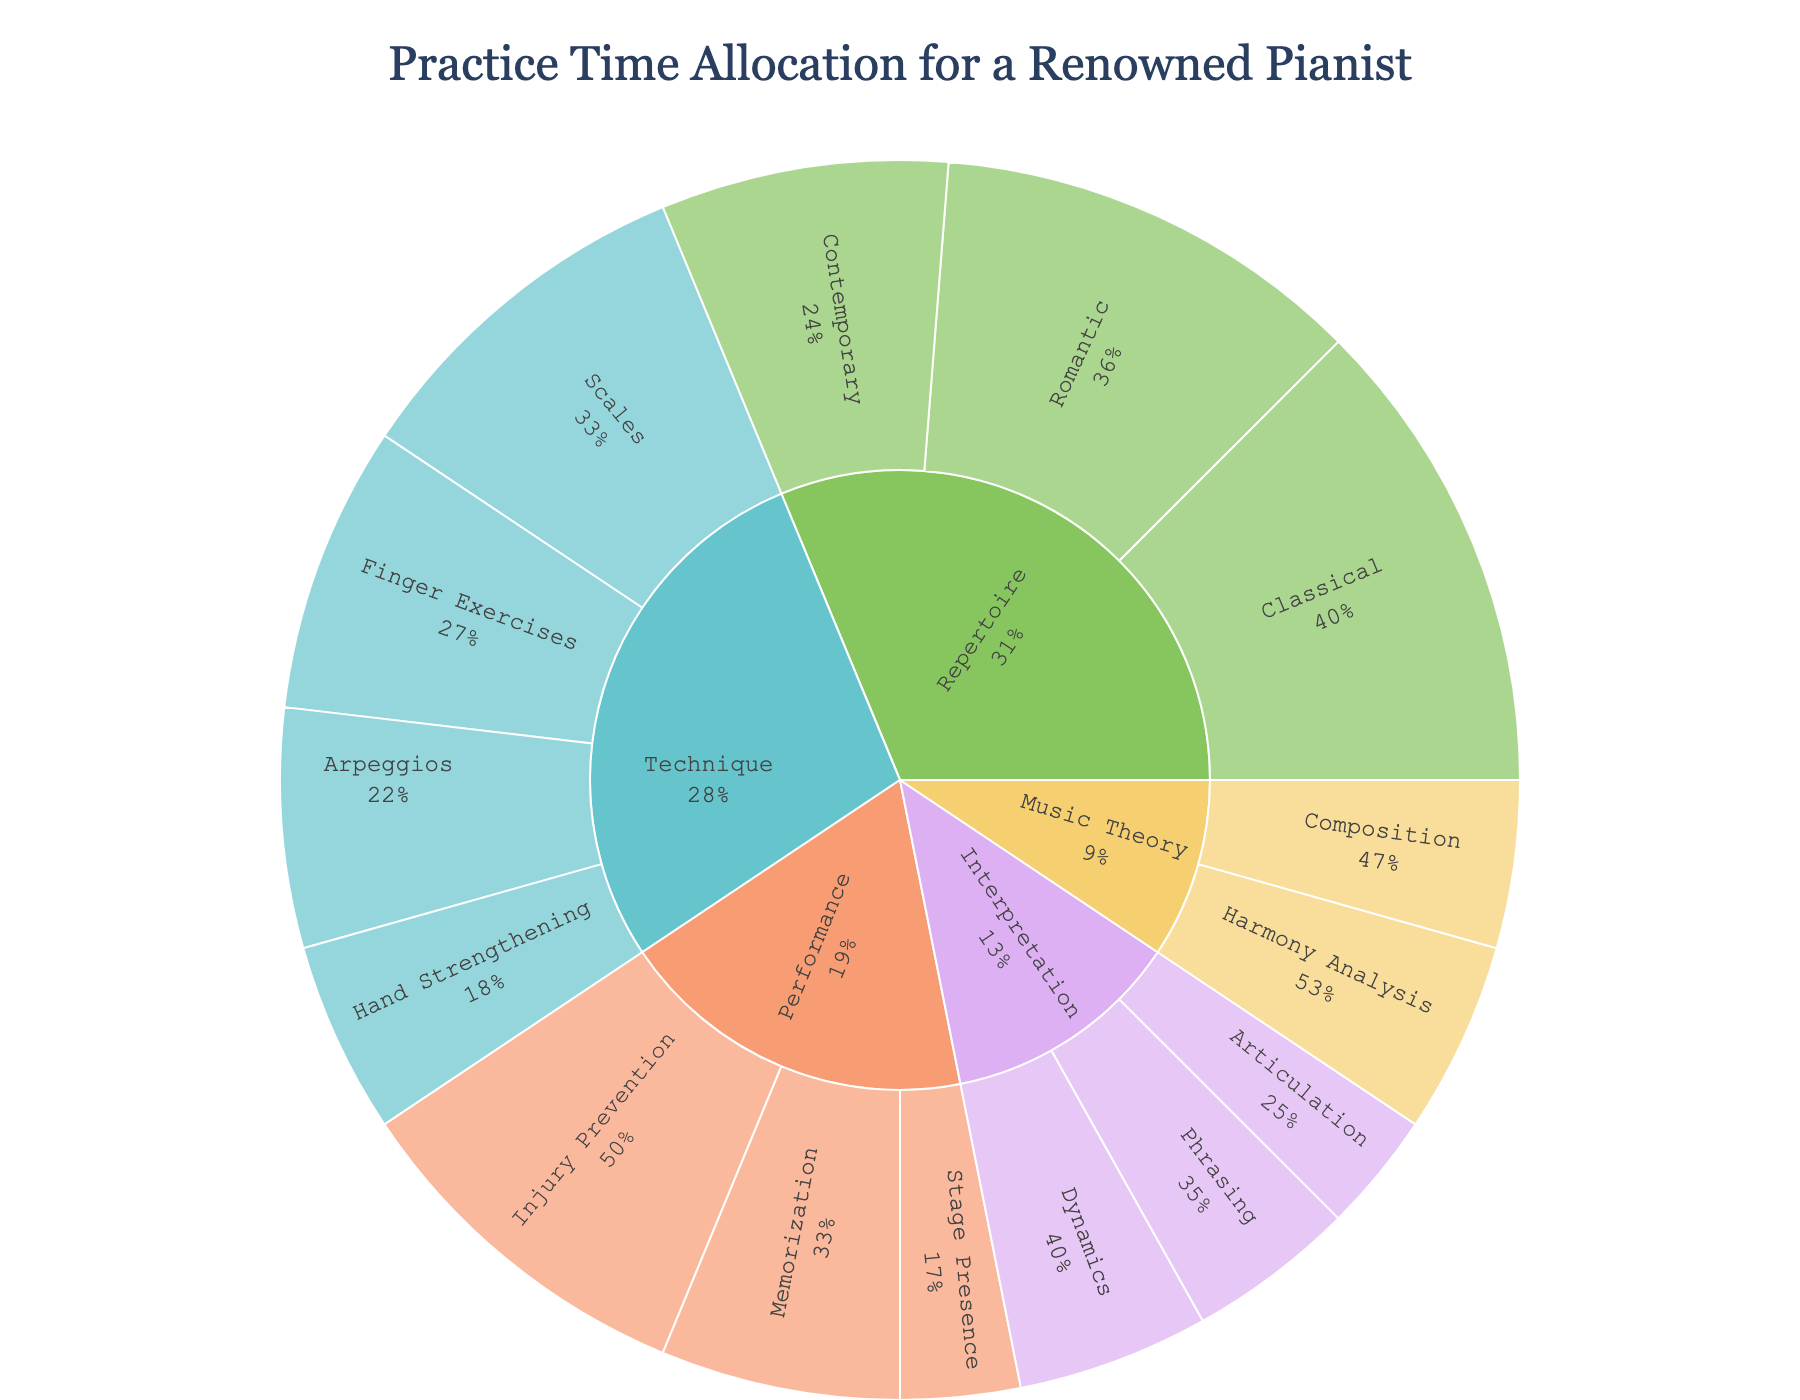what is the title of the plot? The title is displayed at the top of the figure, which is centered and larger in font size. By reading the text, we can identify that it labels the content and purpose of the plot.
Answer: Practice Time Allocation for a Renowned Pianist Which category has the largest allocation of practice time? Observe the size of the outer segments of each category in the Sunburst Plot. The segments will vary in proportion to the value they represent, and the largest one will cover the most area.
Answer: Repertoire What percentage of practice time is allocated to Injury Prevention under Performance? Look at the Performance section of the plot and find the Injury Prevention subcategory. The percentage is directly shown on the segment as a part of Performance.
Answer: 37.5% What is the combined practice time for Scales and Arpeggios? Find the values for Scales and Arpeggios in the Technique category, then sum them. Scales has 15 units, and Arpeggios has 10 units.
Answer: 25 Which is higher: the practice time allocated to Romantic Repertoire or Contemporary Repertoire? Compare the size of the segments for Romantic and Contemporary under the Repertoire category. The one with the larger segment holds a higher value.
Answer: Romantic Repertoire What is the average practice time allocated to the Interpretation subcategories? Sum the values of the Dynamics, Phrasing, and Articulation subcategories in the Interpretation category, and then divide by the number of subcategories. (8 + 7 + 5) / 3.
Answer: 6.7 How much more practice time is allocated to Classical Repertoire compared to Contemporary Repertoire? Identify the values for Classical and Contemporary Repertoire and subtract the latter from the former. Classical is 20, and Contemporary is 12.
Answer: 8 Which subcategory under Music Theory has more allocated practice time? Compare the segments for Harmony Analysis and Composition under Music Theory. The one with a larger segment indicates more practice time.
Answer: Harmony Analysis What percentage of total technique practice time is allocated to Finger Exercises? Find the Finger Exercises value (12) and the total time for all Technique subcategories. Sum Technique values (15 + 10 + 12 + 8 = 45) and divide 12 by 45, then multiply by 100 for the percentage.
Answer: 26.7% How does the allocation of practice time for Memorization compare to Hand Strengthening? Compare the sizes of the segments for Memorization under Performance and Hand Strengthening under Technique.
Answer: Memorization has more practice time 